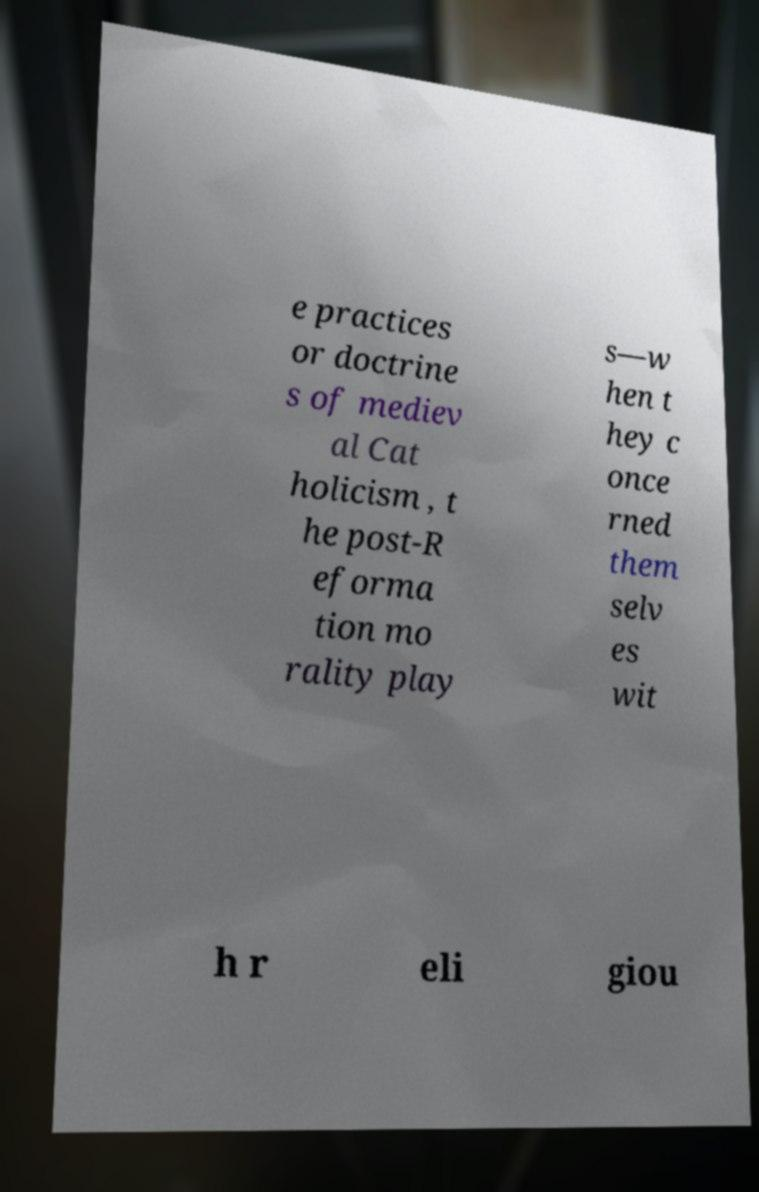Can you read and provide the text displayed in the image?This photo seems to have some interesting text. Can you extract and type it out for me? e practices or doctrine s of mediev al Cat holicism , t he post-R eforma tion mo rality play s—w hen t hey c once rned them selv es wit h r eli giou 